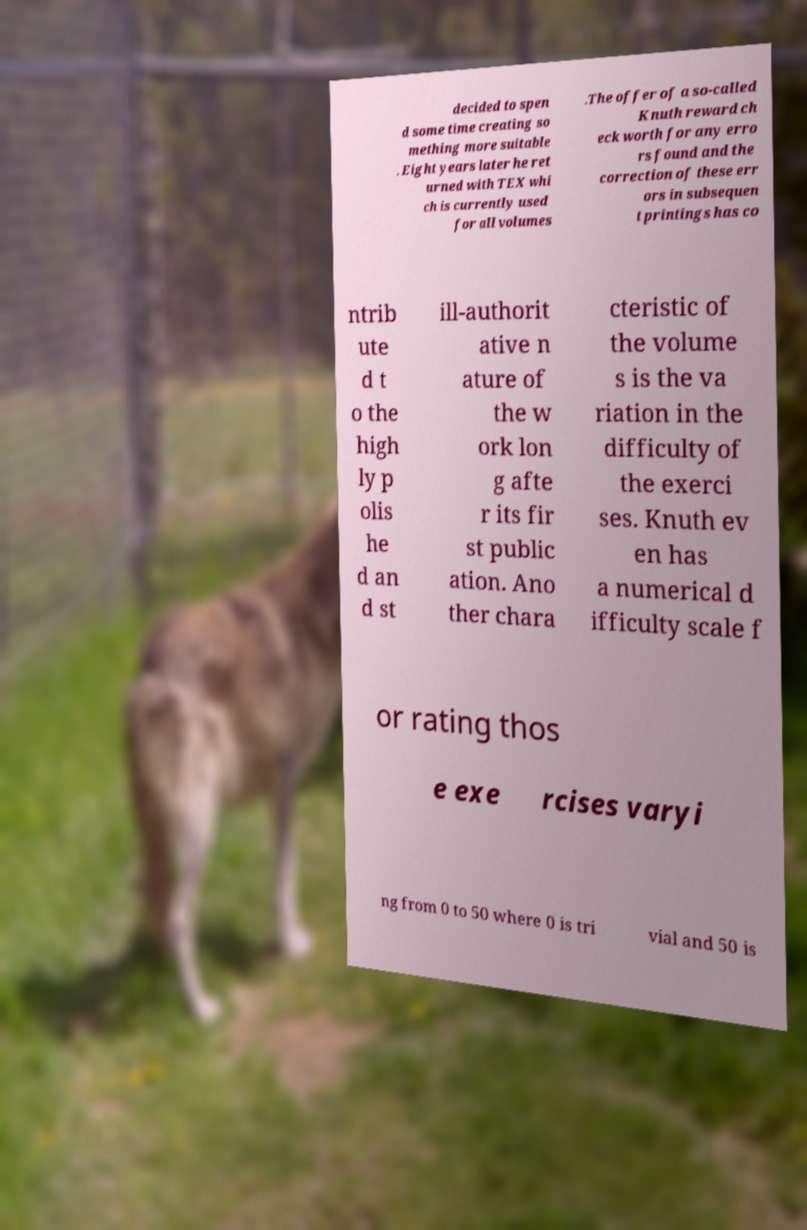There's text embedded in this image that I need extracted. Can you transcribe it verbatim? decided to spen d some time creating so mething more suitable . Eight years later he ret urned with TEX whi ch is currently used for all volumes .The offer of a so-called Knuth reward ch eck worth for any erro rs found and the correction of these err ors in subsequen t printings has co ntrib ute d t o the high ly p olis he d an d st ill-authorit ative n ature of the w ork lon g afte r its fir st public ation. Ano ther chara cteristic of the volume s is the va riation in the difficulty of the exerci ses. Knuth ev en has a numerical d ifficulty scale f or rating thos e exe rcises varyi ng from 0 to 50 where 0 is tri vial and 50 is 